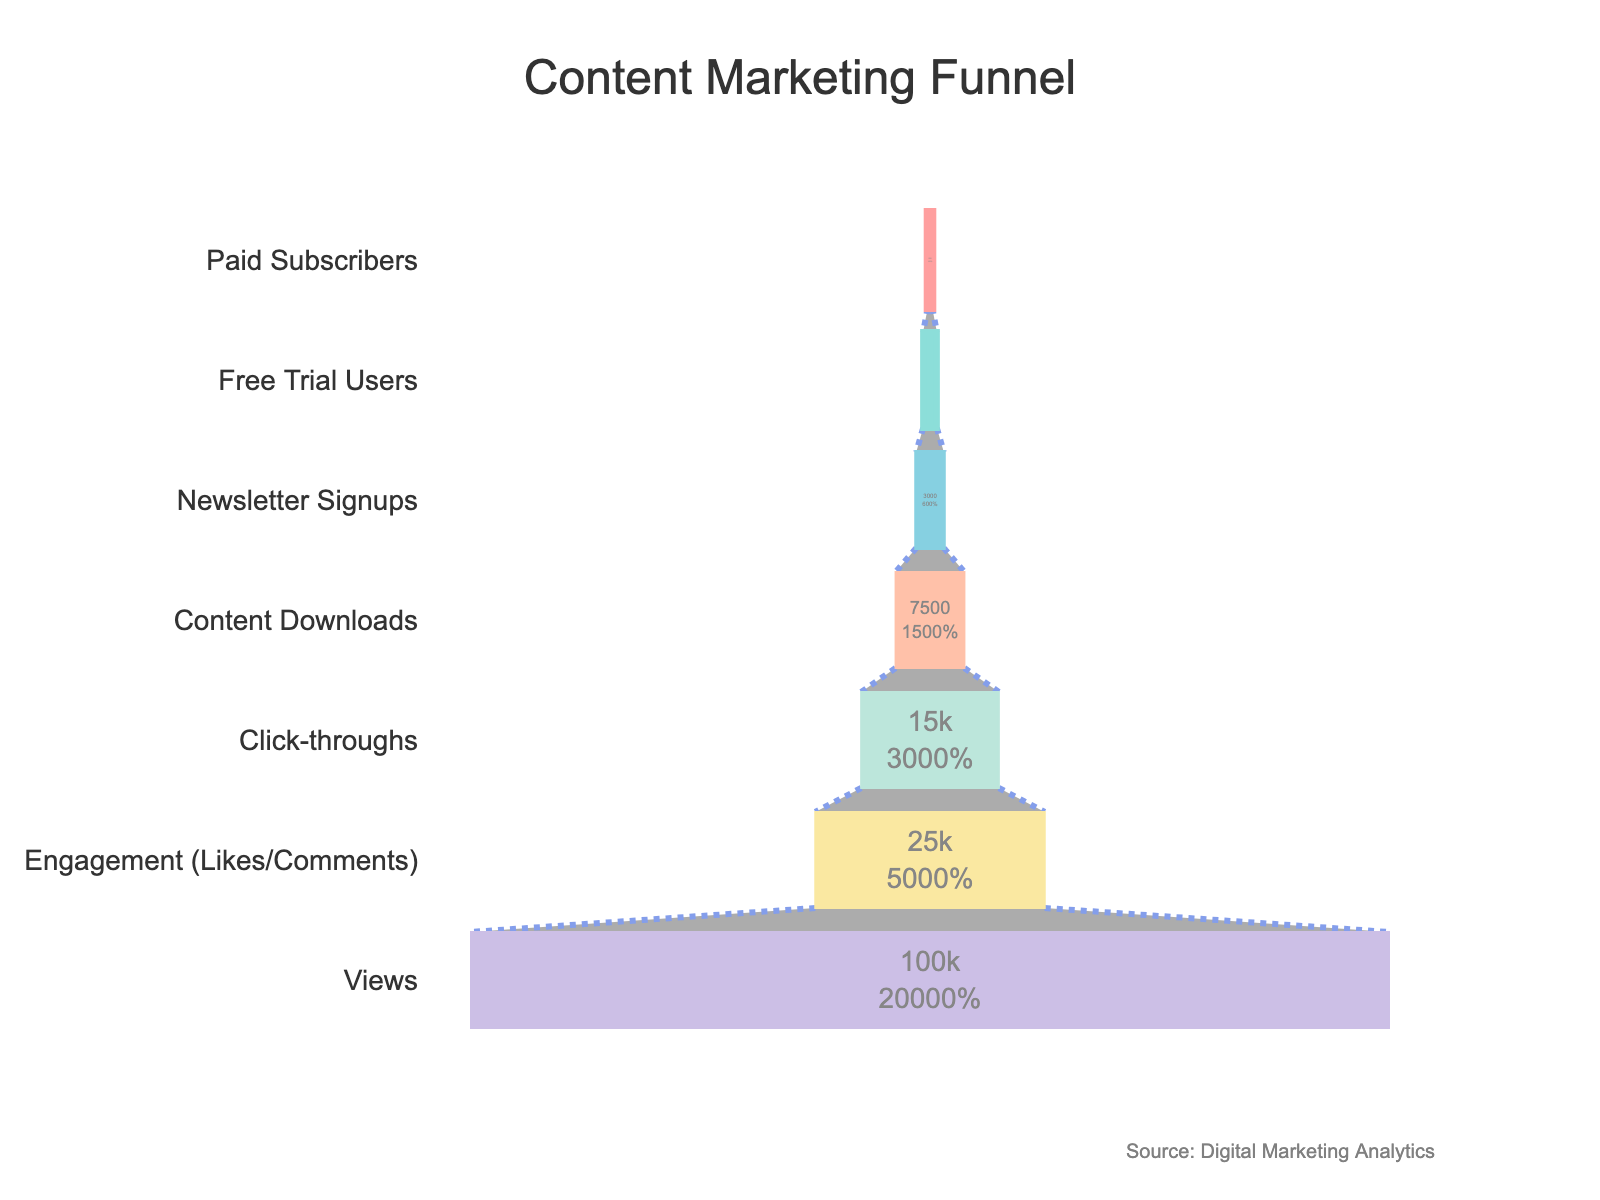What's the title of the figure? The title is located at the top center of the figure and is typically written in a larger font size. Here, it reads "Content Marketing Funnel".
Answer: Content Marketing Funnel How many stages are conveyed in the funnel chart? To determine the number of stages, identify each distinct row labeled with a stage name on the y-axis.
Answer: 7 At what stage does the engagement (likes/comments) occur, and how many users does it involve? Locate the stage labeled "Engagement (Likes/Comments)" and read the corresponding value on the x-axis, which represents the number of users.
Answer: Engagement (Likes/Comments), 25000 How many more users viewed the content than downloaded it? Subtract the number of users at the "Content Downloads" stage from the number of users at the "Views" stage: 100000 (Views) - 7500 (Content Downloads).
Answer: 92500 What percentage of users who engaged with the content went on to click-through? Divide the number of users who clicked-through (15000) by the number of users who engaged with the content (25000) and multiply by 100: (15000 / 25000) * 100.
Answer: 60% How many steps does it take for users to become paid subscribers starting from views? Count the stages from "Views" to "Paid Subscribers": Views, Engagement (Likes/Comments), Click-throughs, Content Downloads, Newsletter Signups, Free Trial Users, Paid Subscribers.
Answer: 6 Which stage has the fewest users in the funnel? Identify the stage with the smallest value on the x-axis.
Answer: Paid Subscribers At which stage is there a significant drop in user engagement, and how many users does it involve? Examine the differences in user numbers between consecutive stages to identify the largest drop: compare the difference between "Views" (100000) and "Engagement (Likes/Comments)" (25000), showing a drop of 75000 users.
Answer: From Views to Engagement (Likes/Comments), 75000 users How does the number of users who signed up for the newsletter compare to those who started a free trial? Compare the "Newsletter Signups" value (3000) with the "Free Trial Users" value (1500) to see which has more users.
Answer: Newsletter Signups: 3000, Free Trial Users: 1500 What proportion of the total initial views convert to free trial users? Divide the number of free trial users (1500) by the number of initial views (100000) and multiply by 100 for the percentage: (1500 / 100000) * 100.
Answer: 1.5% 